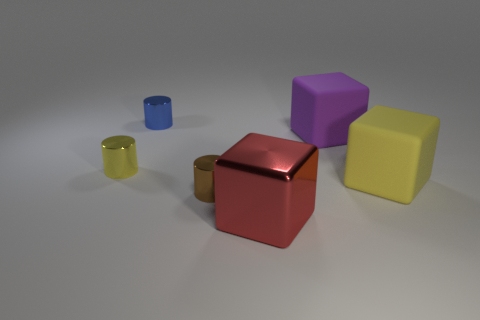Add 3 large metallic cubes. How many objects exist? 9 Subtract 0 purple cylinders. How many objects are left? 6 Subtract all big metal things. Subtract all big blocks. How many objects are left? 2 Add 3 small metal cylinders. How many small metal cylinders are left? 6 Add 1 large metallic blocks. How many large metallic blocks exist? 2 